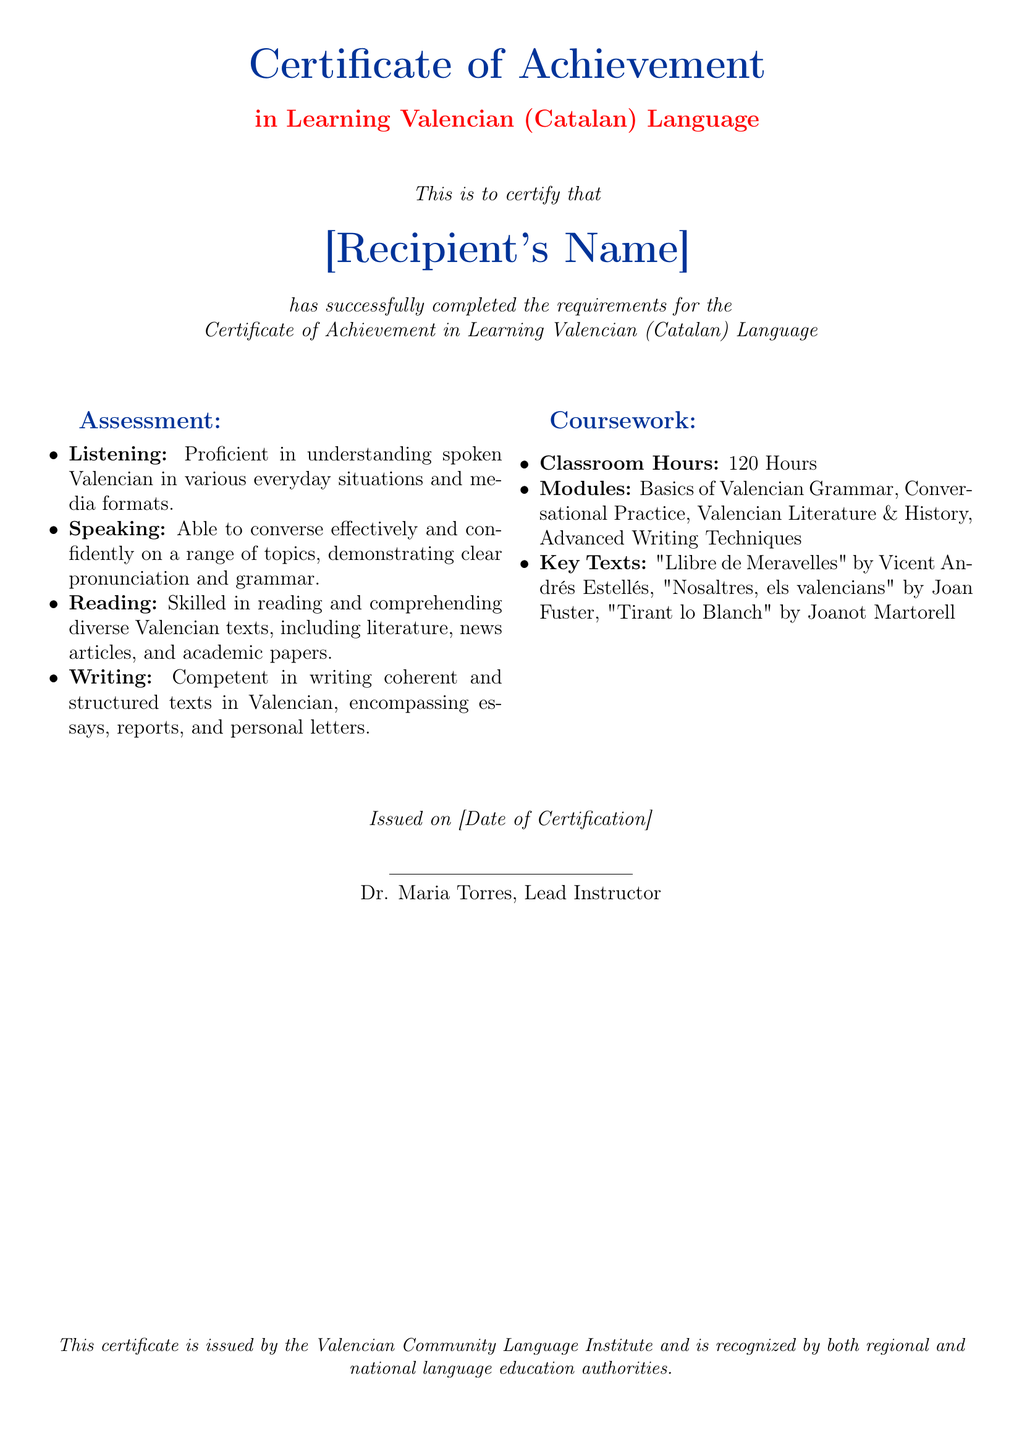what is the recipient's name? The recipient's name is presented in a placeholder format in the document, indicating where the name would be included.
Answer: [Recipient's Name] who issued the certificate? The document specifies the issuer and the lead instructor responsible for this certificate.
Answer: Dr. Maria Torres what is the total number of classroom hours? The document lists the total hours for the course, necessary for the achievement of the certificate.
Answer: 120 Hours what types of assessments are included? The document outlines different categories in which the recipient is assessed, it lists specific areas of language proficiency.
Answer: Listening, Speaking, Reading, Writing how many modules are part of the coursework? The document mentions the number of distinct modules that comprise the entire course structure.
Answer: 4 which institute issued the certificate? The certificate includes the name of the institution that authorized the certification.
Answer: Valencian Community Language Institute what is one key text mentioned in the coursework? The document lists important literature considered part of the coursework, requiring the recipient to engage with these texts.
Answer: "Llibre de Meravelles" what date is the certificate issued? The document mentions a placeholder indicating the issuance date of the certificate.
Answer: [Date of Certification] what is the proficiency level in speaking? The document describes the level of proficiency expected and their capabilities in speaking Valencian.
Answer: Able to converse effectively and confidently 